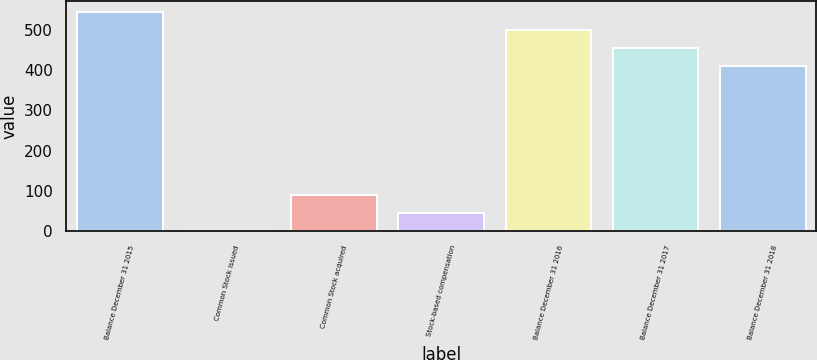Convert chart to OTSL. <chart><loc_0><loc_0><loc_500><loc_500><bar_chart><fcel>Balance December 31 2015<fcel>Common Stock issued<fcel>Common Stock acquired<fcel>Stock-based compensation<fcel>Balance December 31 2016<fcel>Balance December 31 2017<fcel>Balance December 31 2018<nl><fcel>544.77<fcel>0.16<fcel>89.54<fcel>44.85<fcel>500.08<fcel>455.39<fcel>410.7<nl></chart> 